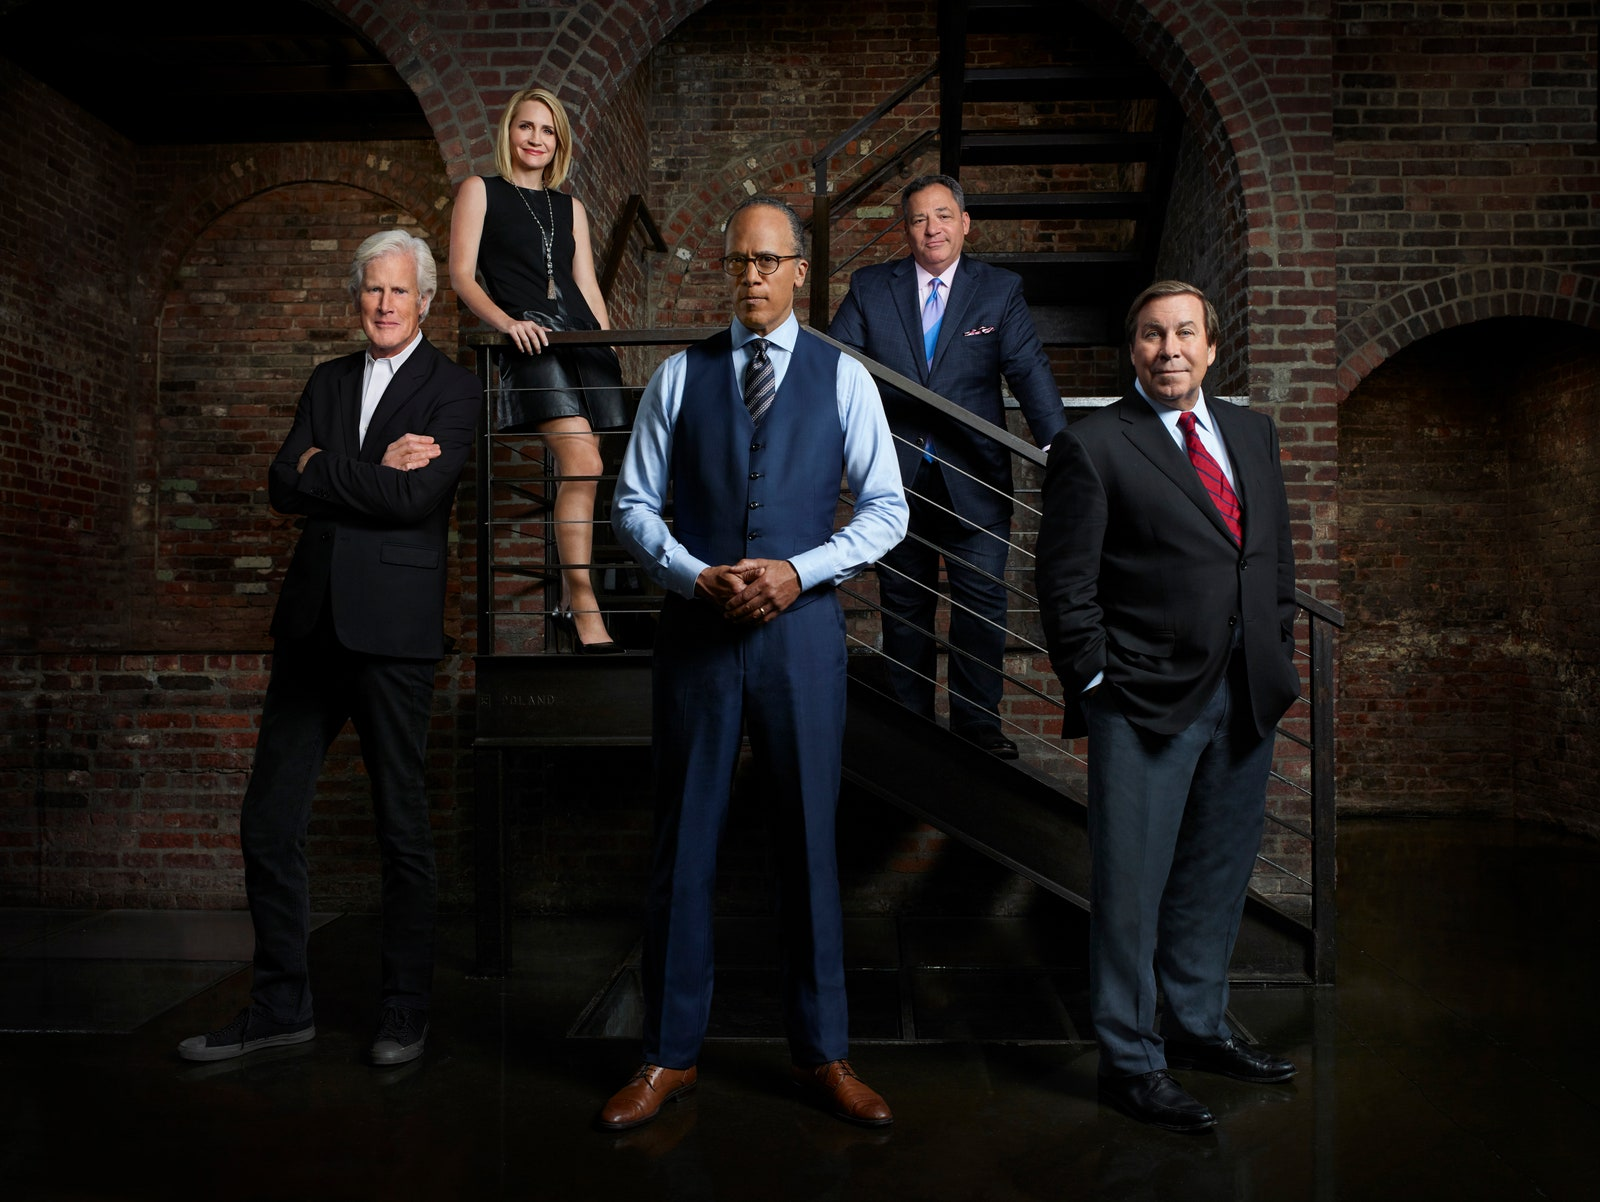Imagine a scenario where these individuals are part of a live-action movie. What genre would it be and how might their characters be involved in the plot? This image lends itself well to the genre of a corporate thriller or a dramatic legal drama. The individuals could be characters central to a gripping plot involving high-stakes mergers, corporate espionage, or a landmark legal case. The central figure, dressed impeccably in a vest, could be the determined protagonist—perhaps a seasoned lawyer or a savvy CEO—leading his team through a series of challenging and suspenseful scenarios. The other members might represent his reliable associates, each bringing a unique skill set crucial to the unfolding drama. What if this was a sci-fi setting? How would you envision their roles? In a sci-fi setting, these individuals might be seen as the elite members of a futuristic corporation that has immense control over advanced technology or resources. The central figure might be the visionary leader, guiding his team through conspiracies and technological breakthroughs. The rest of the group could include a genius inventor, a strategic analyst, a robotics expert, and a cybersecurity specialist. Together, they navigate the challenges of a future world, protecting their breakthroughs from falling into the wrong hands while pushing the boundaries of human achievement. Could you create a very creative scenario related to this image, mixing elements from different genres? Imagine a scenario where these individuals are part of a secretive organization that operates at the intersection of law, technology, and supernatural phenomena. The central figure is not just a lawyer; he is also a guardian of ancient secrets that could alter the course of human history. His team includes a high-tech inventor who crafts gadgets that blend cutting-edge technology with mystical artefacts, a charismatic negotiator who can influence minds, a dedicated historian who deciphers ancient texts, and a pragmatic strategist who plans their missions. Together, they are embroiled in a quest to retrieve a powerful relic hidden within an urban landscape, all while evading a shadowy rival organization bent on harnessing its power for nefarious ends. This hybrid plot blends the suspense of a legal thriller, the innovation of science fiction, and the intrigue of the supernatural. 